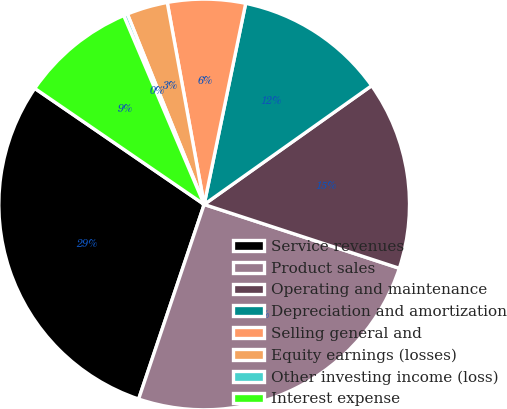Convert chart. <chart><loc_0><loc_0><loc_500><loc_500><pie_chart><fcel>Service revenues<fcel>Product sales<fcel>Operating and maintenance<fcel>Depreciation and amortization<fcel>Selling general and<fcel>Equity earnings (losses)<fcel>Other investing income (loss)<fcel>Interest expense<nl><fcel>29.39%<fcel>25.14%<fcel>14.85%<fcel>11.94%<fcel>6.12%<fcel>3.22%<fcel>0.31%<fcel>9.03%<nl></chart> 